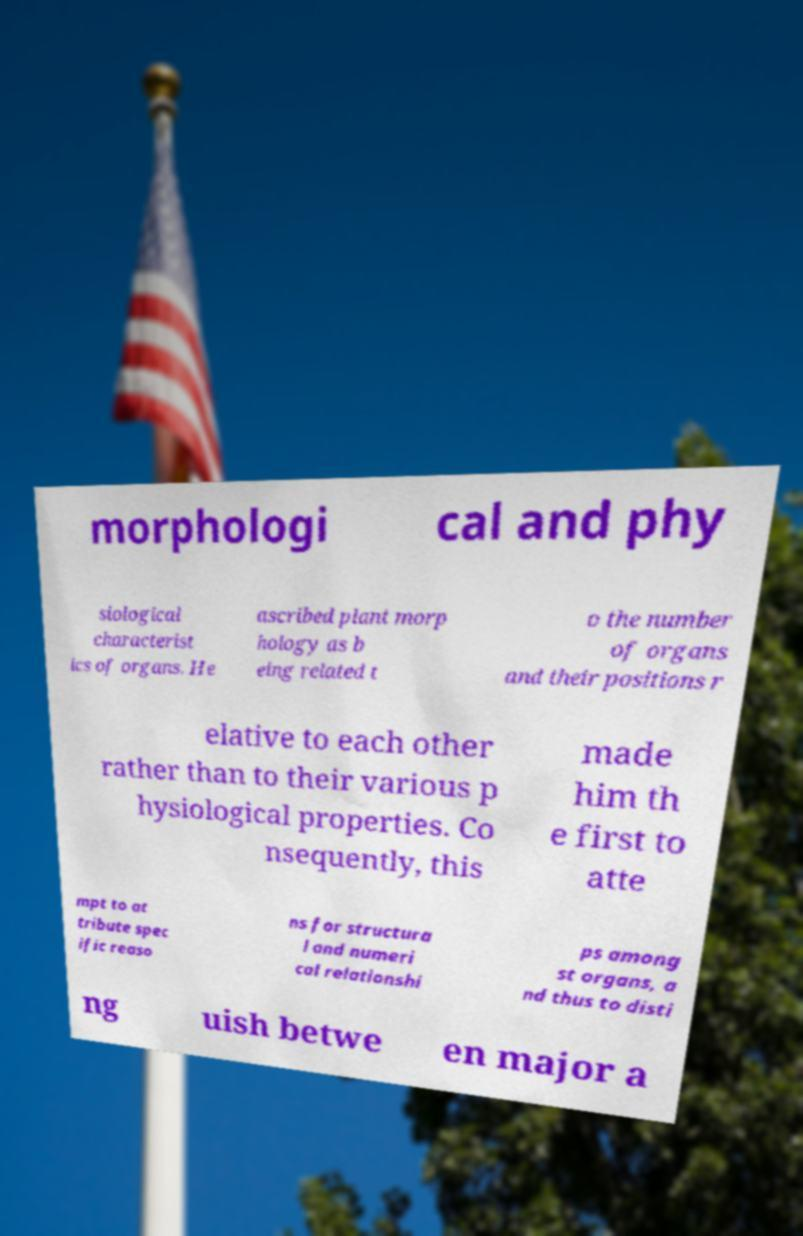For documentation purposes, I need the text within this image transcribed. Could you provide that? morphologi cal and phy siological characterist ics of organs. He ascribed plant morp hology as b eing related t o the number of organs and their positions r elative to each other rather than to their various p hysiological properties. Co nsequently, this made him th e first to atte mpt to at tribute spec ific reaso ns for structura l and numeri cal relationshi ps among st organs, a nd thus to disti ng uish betwe en major a 